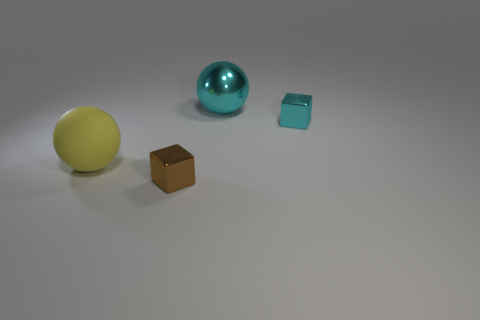Are there fewer big purple blocks than things?
Make the answer very short. Yes. There is a tiny metal thing that is to the left of the cyan object behind the tiny cube behind the big matte sphere; what shape is it?
Provide a short and direct response. Cube. Are there any cyan things made of the same material as the cyan sphere?
Ensure brevity in your answer.  Yes. Do the block that is behind the large yellow rubber ball and the big thing that is to the right of the tiny brown shiny object have the same color?
Your answer should be very brief. Yes. Are there fewer cyan shiny balls that are right of the large cyan shiny sphere than small metallic objects?
Offer a terse response. Yes. What number of things are small purple cubes or brown metallic cubes in front of the yellow rubber thing?
Offer a very short reply. 1. There is a sphere that is made of the same material as the brown block; what color is it?
Ensure brevity in your answer.  Cyan. How many things are large rubber spheres or large green metal blocks?
Offer a very short reply. 1. There is another object that is the same size as the brown shiny thing; what color is it?
Offer a very short reply. Cyan. How many objects are either spheres that are behind the tiny brown shiny block or cyan shiny cubes?
Give a very brief answer. 3. 